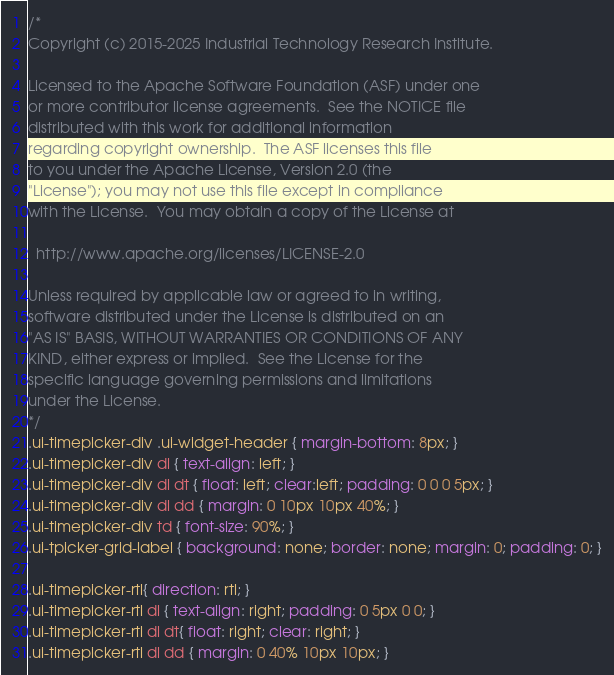<code> <loc_0><loc_0><loc_500><loc_500><_CSS_>/*
Copyright (c) 2015-2025 Industrial Technology Research Institute.

Licensed to the Apache Software Foundation (ASF) under one
or more contributor license agreements.  See the NOTICE file
distributed with this work for additional information
regarding copyright ownership.  The ASF licenses this file
to you under the Apache License, Version 2.0 (the
"License"); you may not use this file except in compliance
with the License.  You may obtain a copy of the License at

  http://www.apache.org/licenses/LICENSE-2.0

Unless required by applicable law or agreed to in writing,
software distributed under the License is distributed on an
"AS IS" BASIS, WITHOUT WARRANTIES OR CONDITIONS OF ANY
KIND, either express or implied.  See the License for the
specific language governing permissions and limitations
under the License.
*/
.ui-timepicker-div .ui-widget-header { margin-bottom: 8px; }
.ui-timepicker-div dl { text-align: left; }
.ui-timepicker-div dl dt { float: left; clear:left; padding: 0 0 0 5px; }
.ui-timepicker-div dl dd { margin: 0 10px 10px 40%; }
.ui-timepicker-div td { font-size: 90%; }
.ui-tpicker-grid-label { background: none; border: none; margin: 0; padding: 0; }

.ui-timepicker-rtl{ direction: rtl; }
.ui-timepicker-rtl dl { text-align: right; padding: 0 5px 0 0; }
.ui-timepicker-rtl dl dt{ float: right; clear: right; }
.ui-timepicker-rtl dl dd { margin: 0 40% 10px 10px; }
</code> 